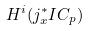<formula> <loc_0><loc_0><loc_500><loc_500>H ^ { i } ( j _ { x } ^ { * } I C _ { p } )</formula> 